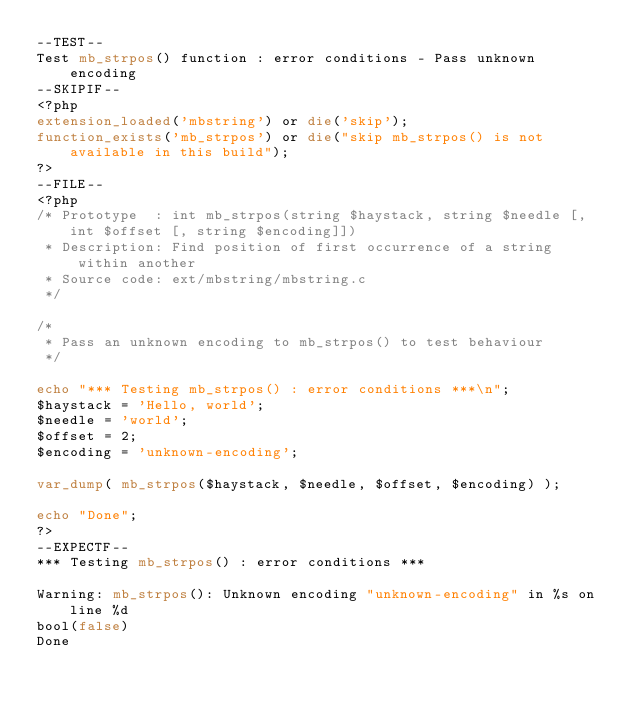<code> <loc_0><loc_0><loc_500><loc_500><_PHP_>--TEST--
Test mb_strpos() function : error conditions - Pass unknown encoding
--SKIPIF--
<?php
extension_loaded('mbstring') or die('skip');
function_exists('mb_strpos') or die("skip mb_strpos() is not available in this build");
?>
--FILE--
<?php
/* Prototype  : int mb_strpos(string $haystack, string $needle [, int $offset [, string $encoding]])
 * Description: Find position of first occurrence of a string within another 
 * Source code: ext/mbstring/mbstring.c
 */

/*
 * Pass an unknown encoding to mb_strpos() to test behaviour
 */

echo "*** Testing mb_strpos() : error conditions ***\n";
$haystack = 'Hello, world';
$needle = 'world';
$offset = 2;
$encoding = 'unknown-encoding';

var_dump( mb_strpos($haystack, $needle, $offset, $encoding) );

echo "Done";
?>
--EXPECTF--
*** Testing mb_strpos() : error conditions ***

Warning: mb_strpos(): Unknown encoding "unknown-encoding" in %s on line %d
bool(false)
Done
</code> 